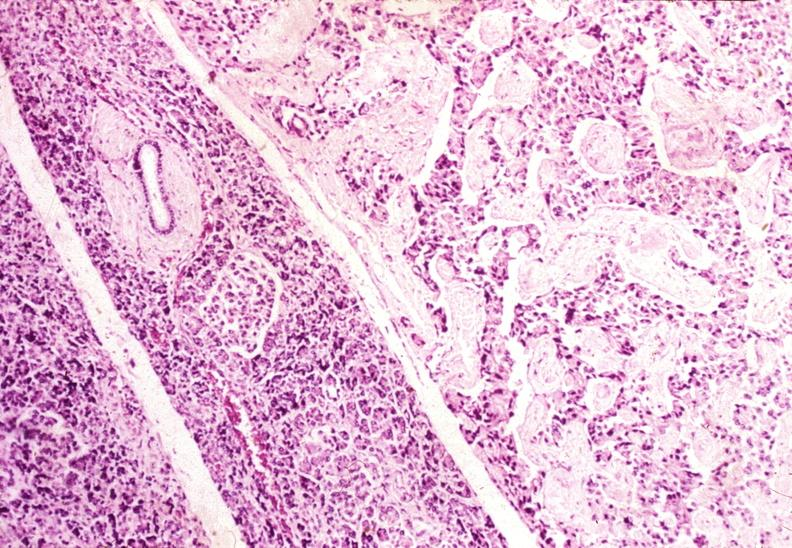does this image show islet cell carcinoma?
Answer the question using a single word or phrase. Yes 